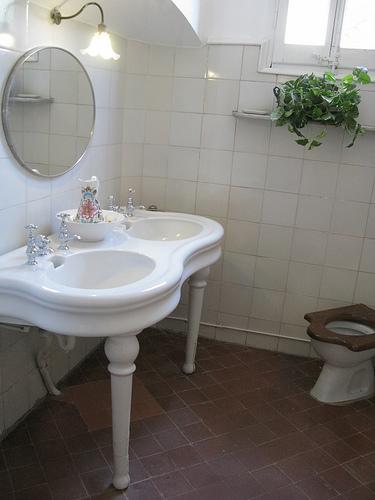How many sinks are there?
Keep it brief. 2. Is there a green plant in this room?
Answer briefly. Yes. Is there a mirror in the bathroom?
Quick response, please. Yes. 